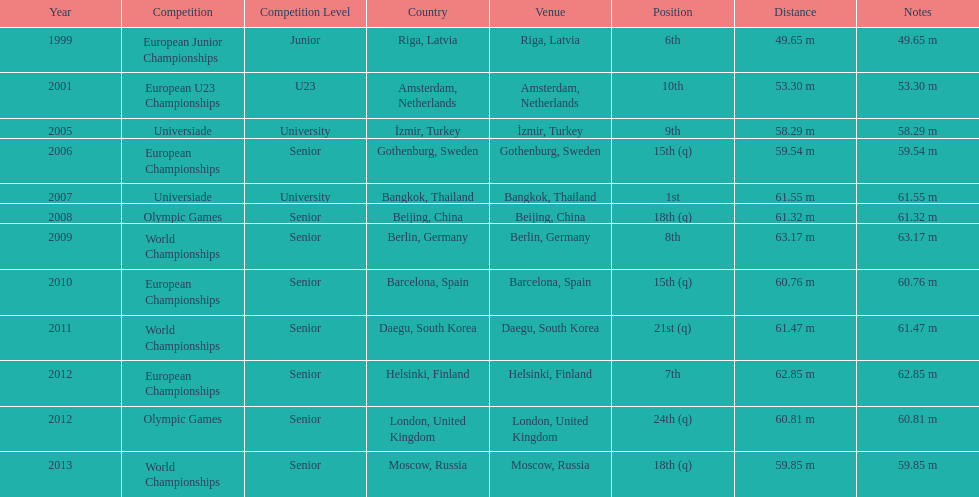What was mayer's top performance: namely, his furthest throw? 63.17 m. 